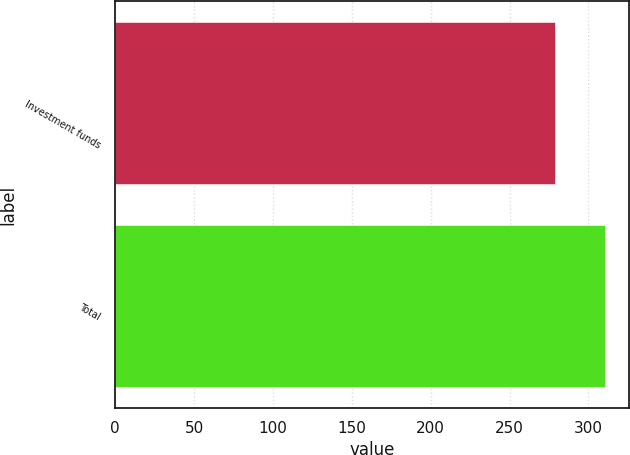Convert chart. <chart><loc_0><loc_0><loc_500><loc_500><bar_chart><fcel>Investment funds<fcel>Total<nl><fcel>279<fcel>310.3<nl></chart> 